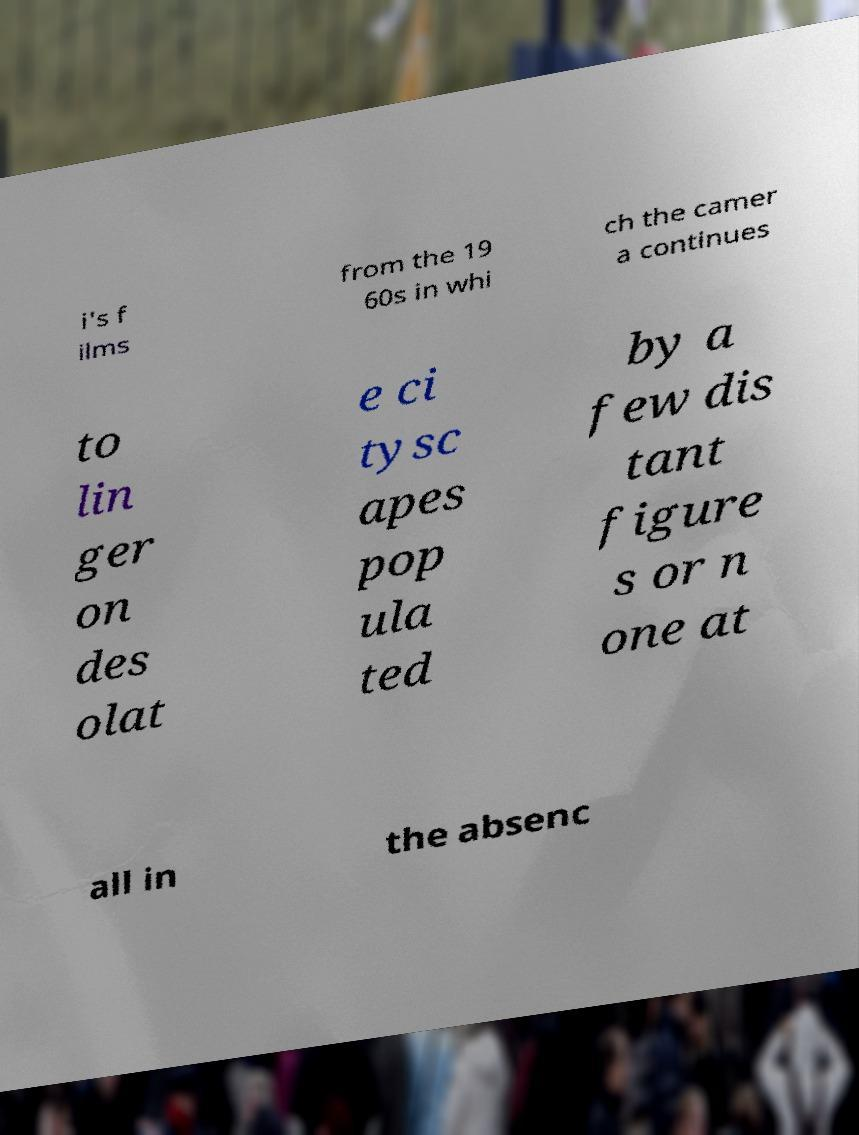Can you accurately transcribe the text from the provided image for me? i's f ilms from the 19 60s in whi ch the camer a continues to lin ger on des olat e ci tysc apes pop ula ted by a few dis tant figure s or n one at all in the absenc 